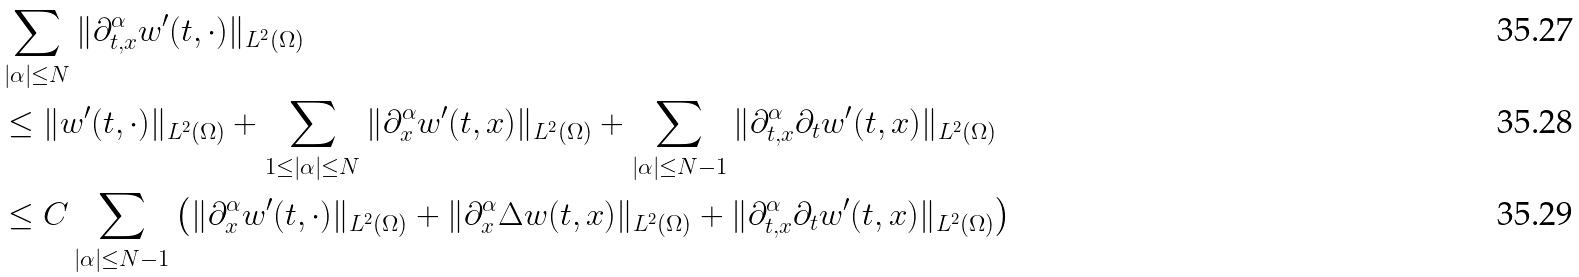<formula> <loc_0><loc_0><loc_500><loc_500>& \sum _ { | \alpha | \leq N } \| \partial ^ { \alpha } _ { t , x } w ^ { \prime } ( t , \cdot ) \| _ { L ^ { 2 } ( \Omega ) } \\ & \leq \| w ^ { \prime } ( t , \cdot ) \| _ { L ^ { 2 } ( \Omega ) } + \sum _ { 1 \leq | \alpha | \leq N } \| \partial _ { x } ^ { \alpha } w ^ { \prime } ( t , x ) \| _ { L ^ { 2 } ( \Omega ) } + \sum _ { | \alpha | \leq N - 1 } \| \partial ^ { \alpha } _ { t , x } \partial _ { t } w ^ { \prime } ( t , x ) \| _ { L ^ { 2 } ( \Omega ) } \\ & \leq C \sum _ { | \alpha | \leq N - 1 } \left ( \| \partial _ { x } ^ { \alpha } w ^ { \prime } ( t , \cdot ) \| _ { L ^ { 2 } ( \Omega ) } + \| \partial _ { x } ^ { \alpha } \Delta w ( t , x ) \| _ { L ^ { 2 } ( \Omega ) } + \| \partial ^ { \alpha } _ { t , x } \partial _ { t } w ^ { \prime } ( t , x ) \| _ { L ^ { 2 } ( \Omega ) } \right )</formula> 